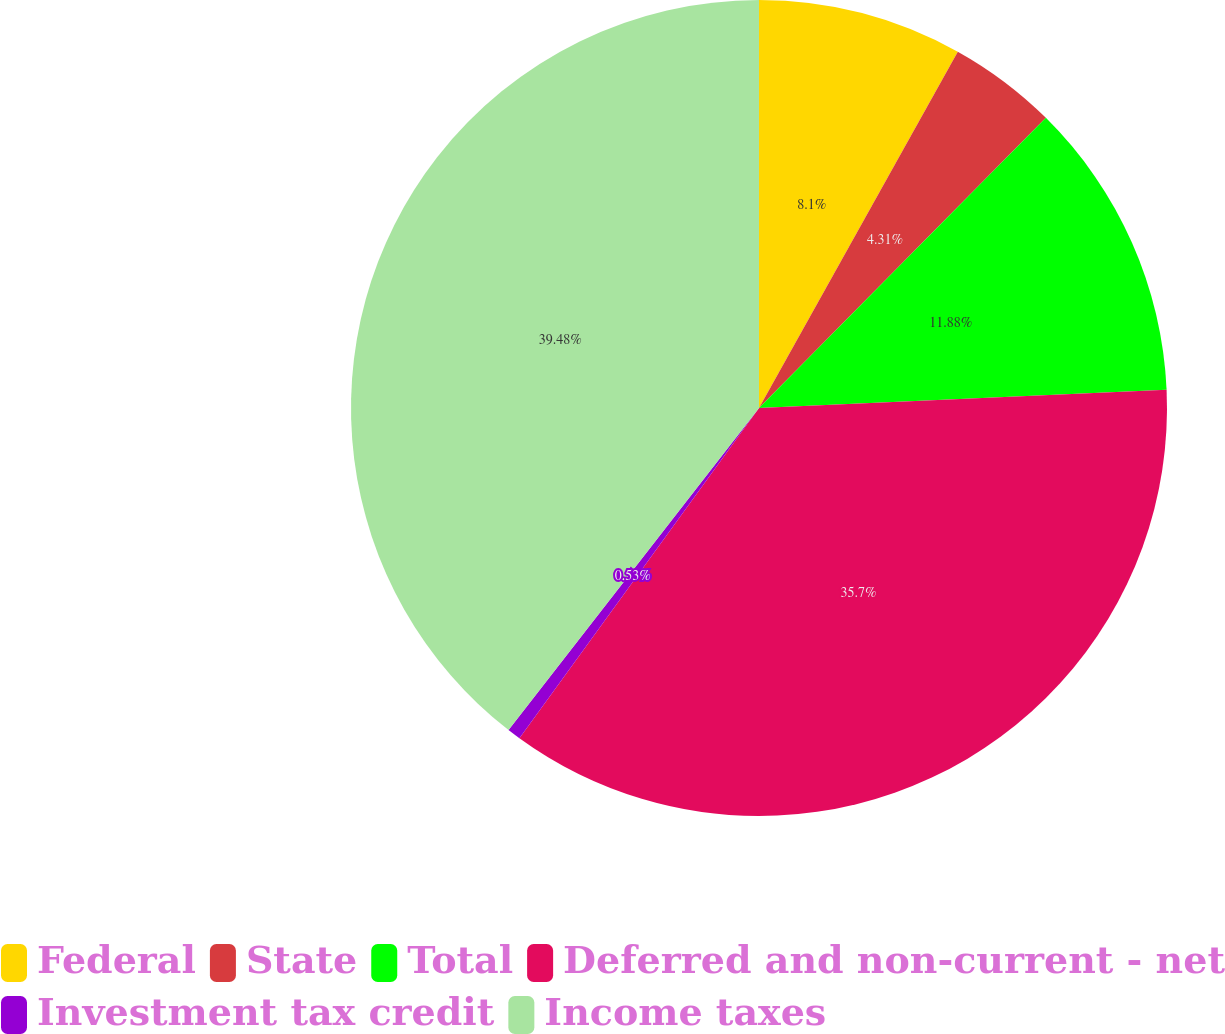Convert chart. <chart><loc_0><loc_0><loc_500><loc_500><pie_chart><fcel>Federal<fcel>State<fcel>Total<fcel>Deferred and non-current - net<fcel>Investment tax credit<fcel>Income taxes<nl><fcel>8.1%<fcel>4.31%<fcel>11.88%<fcel>35.7%<fcel>0.53%<fcel>39.48%<nl></chart> 